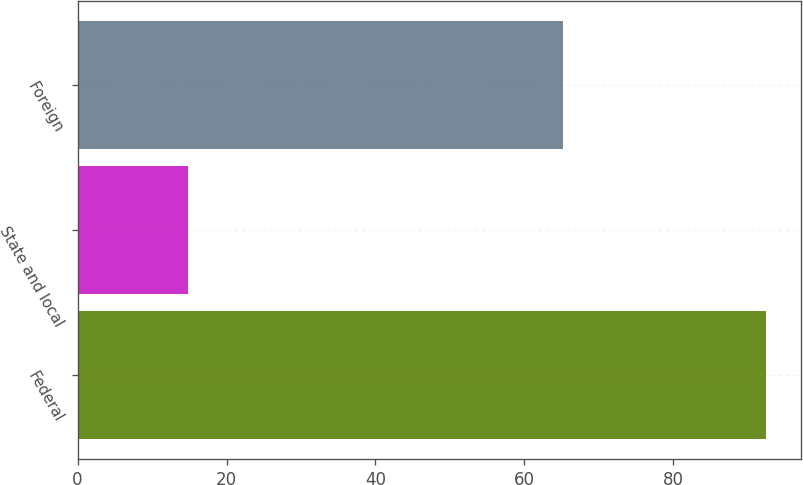Convert chart. <chart><loc_0><loc_0><loc_500><loc_500><bar_chart><fcel>Federal<fcel>State and local<fcel>Foreign<nl><fcel>92.5<fcel>14.8<fcel>65.2<nl></chart> 